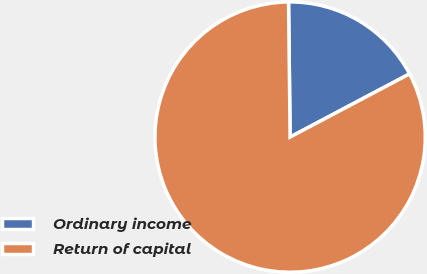Convert chart to OTSL. <chart><loc_0><loc_0><loc_500><loc_500><pie_chart><fcel>Ordinary income<fcel>Return of capital<nl><fcel>17.44%<fcel>82.56%<nl></chart> 